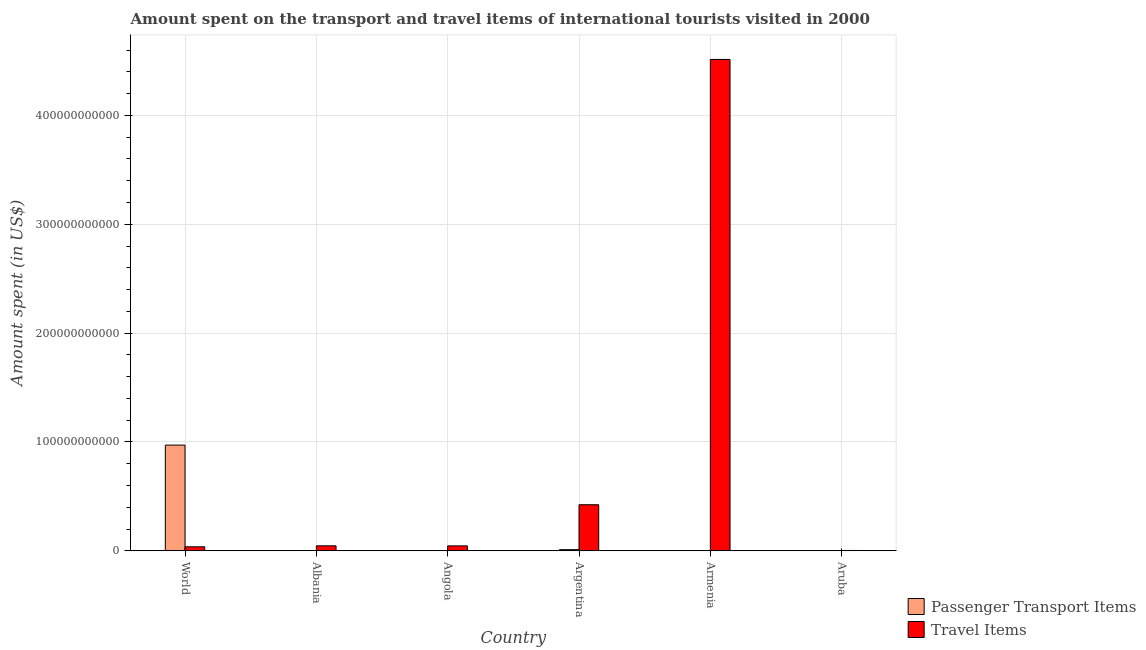How many different coloured bars are there?
Make the answer very short. 2. How many bars are there on the 1st tick from the left?
Your response must be concise. 2. What is the label of the 5th group of bars from the left?
Give a very brief answer. Armenia. In how many cases, is the number of bars for a given country not equal to the number of legend labels?
Provide a short and direct response. 0. What is the amount spent in travel items in World?
Make the answer very short. 3.64e+09. Across all countries, what is the maximum amount spent on passenger transport items?
Your response must be concise. 9.71e+1. In which country was the amount spent in travel items maximum?
Ensure brevity in your answer.  Armenia. In which country was the amount spent in travel items minimum?
Give a very brief answer. Aruba. What is the total amount spent in travel items in the graph?
Your answer should be compact. 5.07e+11. What is the difference between the amount spent on passenger transport items in Armenia and that in World?
Provide a short and direct response. -9.71e+1. What is the difference between the amount spent on passenger transport items in Aruba and the amount spent in travel items in Armenia?
Give a very brief answer. -4.51e+11. What is the average amount spent on passenger transport items per country?
Your response must be concise. 1.64e+1. What is the difference between the amount spent in travel items and amount spent on passenger transport items in Argentina?
Offer a terse response. 4.13e+1. Is the difference between the amount spent on passenger transport items in Armenia and World greater than the difference between the amount spent in travel items in Armenia and World?
Provide a succinct answer. No. What is the difference between the highest and the second highest amount spent on passenger transport items?
Ensure brevity in your answer.  9.61e+1. What is the difference between the highest and the lowest amount spent on passenger transport items?
Provide a short and direct response. 9.71e+1. What does the 1st bar from the left in World represents?
Keep it short and to the point. Passenger Transport Items. What does the 1st bar from the right in Aruba represents?
Make the answer very short. Travel Items. How many bars are there?
Keep it short and to the point. 12. Are all the bars in the graph horizontal?
Your response must be concise. No. What is the difference between two consecutive major ticks on the Y-axis?
Your response must be concise. 1.00e+11. Are the values on the major ticks of Y-axis written in scientific E-notation?
Provide a short and direct response. No. Does the graph contain any zero values?
Make the answer very short. No. How are the legend labels stacked?
Your answer should be very brief. Vertical. What is the title of the graph?
Provide a succinct answer. Amount spent on the transport and travel items of international tourists visited in 2000. What is the label or title of the X-axis?
Provide a succinct answer. Country. What is the label or title of the Y-axis?
Give a very brief answer. Amount spent (in US$). What is the Amount spent (in US$) in Passenger Transport Items in World?
Give a very brief answer. 9.71e+1. What is the Amount spent (in US$) of Travel Items in World?
Give a very brief answer. 3.64e+09. What is the Amount spent (in US$) in Passenger Transport Items in Albania?
Offer a very short reply. 1.80e+07. What is the Amount spent (in US$) of Travel Items in Albania?
Make the answer very short. 4.55e+09. What is the Amount spent (in US$) in Travel Items in Angola?
Give a very brief answer. 4.49e+09. What is the Amount spent (in US$) in Passenger Transport Items in Argentina?
Provide a succinct answer. 1.04e+09. What is the Amount spent (in US$) of Travel Items in Argentina?
Make the answer very short. 4.23e+1. What is the Amount spent (in US$) in Passenger Transport Items in Armenia?
Keep it short and to the point. 1.60e+07. What is the Amount spent (in US$) in Travel Items in Armenia?
Give a very brief answer. 4.51e+11. What is the Amount spent (in US$) in Passenger Transport Items in Aruba?
Give a very brief answer. 1.70e+07. What is the Amount spent (in US$) of Travel Items in Aruba?
Offer a terse response. 2.72e+08. Across all countries, what is the maximum Amount spent (in US$) of Passenger Transport Items?
Make the answer very short. 9.71e+1. Across all countries, what is the maximum Amount spent (in US$) of Travel Items?
Make the answer very short. 4.51e+11. Across all countries, what is the minimum Amount spent (in US$) in Passenger Transport Items?
Offer a very short reply. 1.00e+07. Across all countries, what is the minimum Amount spent (in US$) in Travel Items?
Ensure brevity in your answer.  2.72e+08. What is the total Amount spent (in US$) of Passenger Transport Items in the graph?
Offer a very short reply. 9.82e+1. What is the total Amount spent (in US$) in Travel Items in the graph?
Provide a succinct answer. 5.07e+11. What is the difference between the Amount spent (in US$) in Passenger Transport Items in World and that in Albania?
Provide a succinct answer. 9.71e+1. What is the difference between the Amount spent (in US$) in Travel Items in World and that in Albania?
Offer a very short reply. -9.08e+08. What is the difference between the Amount spent (in US$) of Passenger Transport Items in World and that in Angola?
Give a very brief answer. 9.71e+1. What is the difference between the Amount spent (in US$) in Travel Items in World and that in Angola?
Offer a terse response. -8.49e+08. What is the difference between the Amount spent (in US$) of Passenger Transport Items in World and that in Argentina?
Ensure brevity in your answer.  9.61e+1. What is the difference between the Amount spent (in US$) in Travel Items in World and that in Argentina?
Offer a very short reply. -3.87e+1. What is the difference between the Amount spent (in US$) of Passenger Transport Items in World and that in Armenia?
Provide a short and direct response. 9.71e+1. What is the difference between the Amount spent (in US$) in Travel Items in World and that in Armenia?
Make the answer very short. -4.48e+11. What is the difference between the Amount spent (in US$) in Passenger Transport Items in World and that in Aruba?
Your answer should be compact. 9.71e+1. What is the difference between the Amount spent (in US$) in Travel Items in World and that in Aruba?
Provide a succinct answer. 3.37e+09. What is the difference between the Amount spent (in US$) in Travel Items in Albania and that in Angola?
Offer a very short reply. 5.90e+07. What is the difference between the Amount spent (in US$) of Passenger Transport Items in Albania and that in Argentina?
Provide a short and direct response. -1.02e+09. What is the difference between the Amount spent (in US$) in Travel Items in Albania and that in Argentina?
Give a very brief answer. -3.77e+1. What is the difference between the Amount spent (in US$) in Passenger Transport Items in Albania and that in Armenia?
Make the answer very short. 2.00e+06. What is the difference between the Amount spent (in US$) in Travel Items in Albania and that in Armenia?
Keep it short and to the point. -4.47e+11. What is the difference between the Amount spent (in US$) of Passenger Transport Items in Albania and that in Aruba?
Provide a succinct answer. 1.00e+06. What is the difference between the Amount spent (in US$) of Travel Items in Albania and that in Aruba?
Give a very brief answer. 4.28e+09. What is the difference between the Amount spent (in US$) of Passenger Transport Items in Angola and that in Argentina?
Give a very brief answer. -1.02e+09. What is the difference between the Amount spent (in US$) of Travel Items in Angola and that in Argentina?
Give a very brief answer. -3.78e+1. What is the difference between the Amount spent (in US$) of Passenger Transport Items in Angola and that in Armenia?
Offer a very short reply. -6.00e+06. What is the difference between the Amount spent (in US$) in Travel Items in Angola and that in Armenia?
Your answer should be very brief. -4.47e+11. What is the difference between the Amount spent (in US$) of Passenger Transport Items in Angola and that in Aruba?
Your answer should be compact. -7.00e+06. What is the difference between the Amount spent (in US$) of Travel Items in Angola and that in Aruba?
Offer a terse response. 4.22e+09. What is the difference between the Amount spent (in US$) of Passenger Transport Items in Argentina and that in Armenia?
Your answer should be compact. 1.02e+09. What is the difference between the Amount spent (in US$) of Travel Items in Argentina and that in Armenia?
Make the answer very short. -4.09e+11. What is the difference between the Amount spent (in US$) in Passenger Transport Items in Argentina and that in Aruba?
Provide a succinct answer. 1.02e+09. What is the difference between the Amount spent (in US$) of Travel Items in Argentina and that in Aruba?
Offer a terse response. 4.20e+1. What is the difference between the Amount spent (in US$) in Passenger Transport Items in Armenia and that in Aruba?
Your answer should be very brief. -1.00e+06. What is the difference between the Amount spent (in US$) of Travel Items in Armenia and that in Aruba?
Your answer should be compact. 4.51e+11. What is the difference between the Amount spent (in US$) of Passenger Transport Items in World and the Amount spent (in US$) of Travel Items in Albania?
Offer a very short reply. 9.25e+1. What is the difference between the Amount spent (in US$) of Passenger Transport Items in World and the Amount spent (in US$) of Travel Items in Angola?
Offer a terse response. 9.26e+1. What is the difference between the Amount spent (in US$) in Passenger Transport Items in World and the Amount spent (in US$) in Travel Items in Argentina?
Provide a succinct answer. 5.48e+1. What is the difference between the Amount spent (in US$) in Passenger Transport Items in World and the Amount spent (in US$) in Travel Items in Armenia?
Your response must be concise. -3.54e+11. What is the difference between the Amount spent (in US$) of Passenger Transport Items in World and the Amount spent (in US$) of Travel Items in Aruba?
Offer a terse response. 9.68e+1. What is the difference between the Amount spent (in US$) in Passenger Transport Items in Albania and the Amount spent (in US$) in Travel Items in Angola?
Give a very brief answer. -4.47e+09. What is the difference between the Amount spent (in US$) of Passenger Transport Items in Albania and the Amount spent (in US$) of Travel Items in Argentina?
Your answer should be compact. -4.23e+1. What is the difference between the Amount spent (in US$) of Passenger Transport Items in Albania and the Amount spent (in US$) of Travel Items in Armenia?
Your response must be concise. -4.51e+11. What is the difference between the Amount spent (in US$) in Passenger Transport Items in Albania and the Amount spent (in US$) in Travel Items in Aruba?
Make the answer very short. -2.54e+08. What is the difference between the Amount spent (in US$) of Passenger Transport Items in Angola and the Amount spent (in US$) of Travel Items in Argentina?
Offer a very short reply. -4.23e+1. What is the difference between the Amount spent (in US$) of Passenger Transport Items in Angola and the Amount spent (in US$) of Travel Items in Armenia?
Offer a very short reply. -4.51e+11. What is the difference between the Amount spent (in US$) of Passenger Transport Items in Angola and the Amount spent (in US$) of Travel Items in Aruba?
Make the answer very short. -2.62e+08. What is the difference between the Amount spent (in US$) in Passenger Transport Items in Argentina and the Amount spent (in US$) in Travel Items in Armenia?
Keep it short and to the point. -4.50e+11. What is the difference between the Amount spent (in US$) of Passenger Transport Items in Argentina and the Amount spent (in US$) of Travel Items in Aruba?
Make the answer very short. 7.63e+08. What is the difference between the Amount spent (in US$) in Passenger Transport Items in Armenia and the Amount spent (in US$) in Travel Items in Aruba?
Your answer should be very brief. -2.56e+08. What is the average Amount spent (in US$) in Passenger Transport Items per country?
Make the answer very short. 1.64e+1. What is the average Amount spent (in US$) in Travel Items per country?
Ensure brevity in your answer.  8.44e+1. What is the difference between the Amount spent (in US$) in Passenger Transport Items and Amount spent (in US$) in Travel Items in World?
Your answer should be very brief. 9.34e+1. What is the difference between the Amount spent (in US$) in Passenger Transport Items and Amount spent (in US$) in Travel Items in Albania?
Provide a succinct answer. -4.53e+09. What is the difference between the Amount spent (in US$) of Passenger Transport Items and Amount spent (in US$) of Travel Items in Angola?
Provide a short and direct response. -4.48e+09. What is the difference between the Amount spent (in US$) in Passenger Transport Items and Amount spent (in US$) in Travel Items in Argentina?
Your answer should be very brief. -4.13e+1. What is the difference between the Amount spent (in US$) in Passenger Transport Items and Amount spent (in US$) in Travel Items in Armenia?
Ensure brevity in your answer.  -4.51e+11. What is the difference between the Amount spent (in US$) in Passenger Transport Items and Amount spent (in US$) in Travel Items in Aruba?
Make the answer very short. -2.55e+08. What is the ratio of the Amount spent (in US$) of Passenger Transport Items in World to that in Albania?
Your response must be concise. 5393.97. What is the ratio of the Amount spent (in US$) of Travel Items in World to that in Albania?
Keep it short and to the point. 0.8. What is the ratio of the Amount spent (in US$) in Passenger Transport Items in World to that in Angola?
Provide a succinct answer. 9709.15. What is the ratio of the Amount spent (in US$) in Travel Items in World to that in Angola?
Provide a succinct answer. 0.81. What is the ratio of the Amount spent (in US$) in Passenger Transport Items in World to that in Argentina?
Ensure brevity in your answer.  93.81. What is the ratio of the Amount spent (in US$) in Travel Items in World to that in Argentina?
Your answer should be compact. 0.09. What is the ratio of the Amount spent (in US$) of Passenger Transport Items in World to that in Armenia?
Provide a succinct answer. 6068.22. What is the ratio of the Amount spent (in US$) of Travel Items in World to that in Armenia?
Give a very brief answer. 0.01. What is the ratio of the Amount spent (in US$) in Passenger Transport Items in World to that in Aruba?
Offer a terse response. 5711.26. What is the ratio of the Amount spent (in US$) of Travel Items in World to that in Aruba?
Make the answer very short. 13.39. What is the ratio of the Amount spent (in US$) in Travel Items in Albania to that in Angola?
Provide a succinct answer. 1.01. What is the ratio of the Amount spent (in US$) of Passenger Transport Items in Albania to that in Argentina?
Your response must be concise. 0.02. What is the ratio of the Amount spent (in US$) in Travel Items in Albania to that in Argentina?
Make the answer very short. 0.11. What is the ratio of the Amount spent (in US$) in Travel Items in Albania to that in Armenia?
Ensure brevity in your answer.  0.01. What is the ratio of the Amount spent (in US$) in Passenger Transport Items in Albania to that in Aruba?
Make the answer very short. 1.06. What is the ratio of the Amount spent (in US$) of Travel Items in Albania to that in Aruba?
Offer a terse response. 16.73. What is the ratio of the Amount spent (in US$) of Passenger Transport Items in Angola to that in Argentina?
Give a very brief answer. 0.01. What is the ratio of the Amount spent (in US$) in Travel Items in Angola to that in Argentina?
Your answer should be compact. 0.11. What is the ratio of the Amount spent (in US$) of Travel Items in Angola to that in Armenia?
Your answer should be compact. 0.01. What is the ratio of the Amount spent (in US$) in Passenger Transport Items in Angola to that in Aruba?
Make the answer very short. 0.59. What is the ratio of the Amount spent (in US$) in Travel Items in Angola to that in Aruba?
Provide a succinct answer. 16.51. What is the ratio of the Amount spent (in US$) in Passenger Transport Items in Argentina to that in Armenia?
Your answer should be compact. 64.69. What is the ratio of the Amount spent (in US$) in Travel Items in Argentina to that in Armenia?
Your answer should be compact. 0.09. What is the ratio of the Amount spent (in US$) of Passenger Transport Items in Argentina to that in Aruba?
Offer a terse response. 60.88. What is the ratio of the Amount spent (in US$) of Travel Items in Argentina to that in Aruba?
Make the answer very short. 155.5. What is the ratio of the Amount spent (in US$) in Travel Items in Armenia to that in Aruba?
Keep it short and to the point. 1659.64. What is the difference between the highest and the second highest Amount spent (in US$) of Passenger Transport Items?
Provide a succinct answer. 9.61e+1. What is the difference between the highest and the second highest Amount spent (in US$) in Travel Items?
Ensure brevity in your answer.  4.09e+11. What is the difference between the highest and the lowest Amount spent (in US$) in Passenger Transport Items?
Offer a terse response. 9.71e+1. What is the difference between the highest and the lowest Amount spent (in US$) in Travel Items?
Provide a short and direct response. 4.51e+11. 